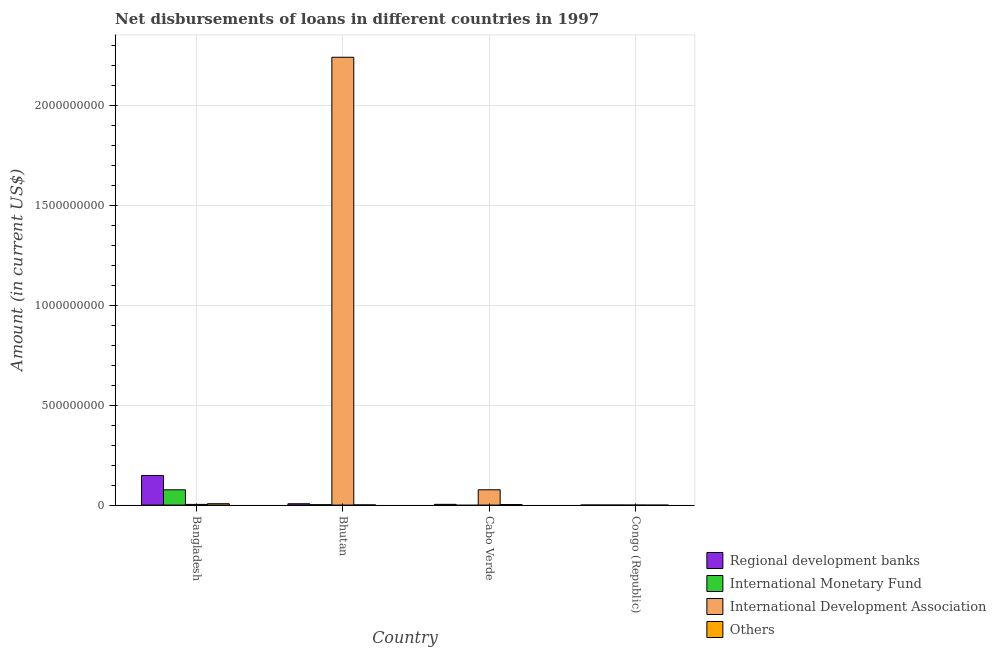How many different coloured bars are there?
Keep it short and to the point. 4. Are the number of bars per tick equal to the number of legend labels?
Keep it short and to the point. No. How many bars are there on the 3rd tick from the right?
Offer a very short reply. 4. What is the label of the 2nd group of bars from the left?
Keep it short and to the point. Bhutan. What is the amount of loan disimbursed by international monetary fund in Bangladesh?
Provide a short and direct response. 7.65e+07. Across all countries, what is the maximum amount of loan disimbursed by international monetary fund?
Your answer should be compact. 7.65e+07. Across all countries, what is the minimum amount of loan disimbursed by international development association?
Make the answer very short. 0. What is the total amount of loan disimbursed by other organisations in the graph?
Your response must be concise. 1.01e+07. What is the difference between the amount of loan disimbursed by international development association in Bhutan and that in Cabo Verde?
Ensure brevity in your answer.  2.17e+09. What is the difference between the amount of loan disimbursed by regional development banks in Congo (Republic) and the amount of loan disimbursed by international monetary fund in Bangladesh?
Make the answer very short. -7.65e+07. What is the average amount of loan disimbursed by other organisations per country?
Provide a short and direct response. 2.52e+06. What is the difference between the amount of loan disimbursed by regional development banks and amount of loan disimbursed by international development association in Bhutan?
Keep it short and to the point. -2.24e+09. In how many countries, is the amount of loan disimbursed by international monetary fund greater than 400000000 US$?
Keep it short and to the point. 0. What is the ratio of the amount of loan disimbursed by international development association in Bangladesh to that in Cabo Verde?
Offer a terse response. 0.04. Is the amount of loan disimbursed by other organisations in Bangladesh less than that in Bhutan?
Provide a succinct answer. No. Is the difference between the amount of loan disimbursed by international monetary fund in Bangladesh and Bhutan greater than the difference between the amount of loan disimbursed by other organisations in Bangladesh and Bhutan?
Offer a terse response. Yes. What is the difference between the highest and the second highest amount of loan disimbursed by other organisations?
Your answer should be very brief. 4.25e+06. What is the difference between the highest and the lowest amount of loan disimbursed by international monetary fund?
Keep it short and to the point. 7.65e+07. How many bars are there?
Make the answer very short. 11. Are all the bars in the graph horizontal?
Offer a very short reply. No. How many countries are there in the graph?
Your response must be concise. 4. What is the difference between two consecutive major ticks on the Y-axis?
Ensure brevity in your answer.  5.00e+08. Are the values on the major ticks of Y-axis written in scientific E-notation?
Make the answer very short. No. Does the graph contain any zero values?
Your response must be concise. Yes. Does the graph contain grids?
Make the answer very short. Yes. How many legend labels are there?
Your response must be concise. 4. How are the legend labels stacked?
Your answer should be very brief. Vertical. What is the title of the graph?
Provide a short and direct response. Net disbursements of loans in different countries in 1997. What is the label or title of the Y-axis?
Your response must be concise. Amount (in current US$). What is the Amount (in current US$) in Regional development banks in Bangladesh?
Provide a succinct answer. 1.48e+08. What is the Amount (in current US$) of International Monetary Fund in Bangladesh?
Ensure brevity in your answer.  7.65e+07. What is the Amount (in current US$) in International Development Association in Bangladesh?
Give a very brief answer. 3.41e+06. What is the Amount (in current US$) in Others in Bangladesh?
Offer a terse response. 6.79e+06. What is the Amount (in current US$) of Regional development banks in Bhutan?
Your response must be concise. 6.68e+06. What is the Amount (in current US$) in International Monetary Fund in Bhutan?
Your answer should be very brief. 1.93e+06. What is the Amount (in current US$) in International Development Association in Bhutan?
Make the answer very short. 2.24e+09. What is the Amount (in current US$) of Others in Bhutan?
Keep it short and to the point. 7.48e+05. What is the Amount (in current US$) of Regional development banks in Cabo Verde?
Give a very brief answer. 3.63e+06. What is the Amount (in current US$) of International Monetary Fund in Cabo Verde?
Your response must be concise. 0. What is the Amount (in current US$) of International Development Association in Cabo Verde?
Provide a short and direct response. 7.65e+07. What is the Amount (in current US$) in Others in Cabo Verde?
Offer a terse response. 2.54e+06. What is the Amount (in current US$) in International Monetary Fund in Congo (Republic)?
Offer a very short reply. 0. What is the Amount (in current US$) of International Development Association in Congo (Republic)?
Offer a terse response. 0. What is the Amount (in current US$) in Others in Congo (Republic)?
Keep it short and to the point. 0. Across all countries, what is the maximum Amount (in current US$) in Regional development banks?
Give a very brief answer. 1.48e+08. Across all countries, what is the maximum Amount (in current US$) of International Monetary Fund?
Offer a terse response. 7.65e+07. Across all countries, what is the maximum Amount (in current US$) of International Development Association?
Provide a succinct answer. 2.24e+09. Across all countries, what is the maximum Amount (in current US$) of Others?
Make the answer very short. 6.79e+06. Across all countries, what is the minimum Amount (in current US$) of International Monetary Fund?
Your response must be concise. 0. Across all countries, what is the minimum Amount (in current US$) in International Development Association?
Provide a short and direct response. 0. Across all countries, what is the minimum Amount (in current US$) of Others?
Your answer should be very brief. 0. What is the total Amount (in current US$) in Regional development banks in the graph?
Your response must be concise. 1.59e+08. What is the total Amount (in current US$) of International Monetary Fund in the graph?
Offer a very short reply. 7.84e+07. What is the total Amount (in current US$) of International Development Association in the graph?
Ensure brevity in your answer.  2.32e+09. What is the total Amount (in current US$) of Others in the graph?
Your response must be concise. 1.01e+07. What is the difference between the Amount (in current US$) of Regional development banks in Bangladesh and that in Bhutan?
Your response must be concise. 1.42e+08. What is the difference between the Amount (in current US$) in International Monetary Fund in Bangladesh and that in Bhutan?
Your answer should be very brief. 7.46e+07. What is the difference between the Amount (in current US$) of International Development Association in Bangladesh and that in Bhutan?
Your response must be concise. -2.24e+09. What is the difference between the Amount (in current US$) of Others in Bangladesh and that in Bhutan?
Your answer should be compact. 6.04e+06. What is the difference between the Amount (in current US$) in Regional development banks in Bangladesh and that in Cabo Verde?
Provide a succinct answer. 1.45e+08. What is the difference between the Amount (in current US$) of International Development Association in Bangladesh and that in Cabo Verde?
Offer a very short reply. -7.31e+07. What is the difference between the Amount (in current US$) in Others in Bangladesh and that in Cabo Verde?
Your answer should be compact. 4.25e+06. What is the difference between the Amount (in current US$) in Regional development banks in Bhutan and that in Cabo Verde?
Provide a short and direct response. 3.05e+06. What is the difference between the Amount (in current US$) in International Development Association in Bhutan and that in Cabo Verde?
Ensure brevity in your answer.  2.17e+09. What is the difference between the Amount (in current US$) in Others in Bhutan and that in Cabo Verde?
Offer a terse response. -1.79e+06. What is the difference between the Amount (in current US$) in Regional development banks in Bangladesh and the Amount (in current US$) in International Monetary Fund in Bhutan?
Your answer should be very brief. 1.46e+08. What is the difference between the Amount (in current US$) in Regional development banks in Bangladesh and the Amount (in current US$) in International Development Association in Bhutan?
Give a very brief answer. -2.09e+09. What is the difference between the Amount (in current US$) in Regional development banks in Bangladesh and the Amount (in current US$) in Others in Bhutan?
Offer a very short reply. 1.48e+08. What is the difference between the Amount (in current US$) of International Monetary Fund in Bangladesh and the Amount (in current US$) of International Development Association in Bhutan?
Provide a short and direct response. -2.17e+09. What is the difference between the Amount (in current US$) of International Monetary Fund in Bangladesh and the Amount (in current US$) of Others in Bhutan?
Offer a terse response. 7.57e+07. What is the difference between the Amount (in current US$) of International Development Association in Bangladesh and the Amount (in current US$) of Others in Bhutan?
Your answer should be compact. 2.66e+06. What is the difference between the Amount (in current US$) in Regional development banks in Bangladesh and the Amount (in current US$) in International Development Association in Cabo Verde?
Your answer should be compact. 7.18e+07. What is the difference between the Amount (in current US$) in Regional development banks in Bangladesh and the Amount (in current US$) in Others in Cabo Verde?
Offer a very short reply. 1.46e+08. What is the difference between the Amount (in current US$) of International Monetary Fund in Bangladesh and the Amount (in current US$) of International Development Association in Cabo Verde?
Offer a terse response. -7000. What is the difference between the Amount (in current US$) of International Monetary Fund in Bangladesh and the Amount (in current US$) of Others in Cabo Verde?
Ensure brevity in your answer.  7.39e+07. What is the difference between the Amount (in current US$) of International Development Association in Bangladesh and the Amount (in current US$) of Others in Cabo Verde?
Provide a succinct answer. 8.71e+05. What is the difference between the Amount (in current US$) in Regional development banks in Bhutan and the Amount (in current US$) in International Development Association in Cabo Verde?
Your answer should be compact. -6.98e+07. What is the difference between the Amount (in current US$) in Regional development banks in Bhutan and the Amount (in current US$) in Others in Cabo Verde?
Your answer should be very brief. 4.14e+06. What is the difference between the Amount (in current US$) in International Monetary Fund in Bhutan and the Amount (in current US$) in International Development Association in Cabo Verde?
Keep it short and to the point. -7.46e+07. What is the difference between the Amount (in current US$) of International Monetary Fund in Bhutan and the Amount (in current US$) of Others in Cabo Verde?
Offer a very short reply. -6.13e+05. What is the difference between the Amount (in current US$) of International Development Association in Bhutan and the Amount (in current US$) of Others in Cabo Verde?
Offer a terse response. 2.24e+09. What is the average Amount (in current US$) of Regional development banks per country?
Make the answer very short. 3.96e+07. What is the average Amount (in current US$) of International Monetary Fund per country?
Your answer should be very brief. 1.96e+07. What is the average Amount (in current US$) in International Development Association per country?
Offer a terse response. 5.81e+08. What is the average Amount (in current US$) in Others per country?
Ensure brevity in your answer.  2.52e+06. What is the difference between the Amount (in current US$) in Regional development banks and Amount (in current US$) in International Monetary Fund in Bangladesh?
Your answer should be very brief. 7.18e+07. What is the difference between the Amount (in current US$) in Regional development banks and Amount (in current US$) in International Development Association in Bangladesh?
Provide a short and direct response. 1.45e+08. What is the difference between the Amount (in current US$) in Regional development banks and Amount (in current US$) in Others in Bangladesh?
Provide a short and direct response. 1.41e+08. What is the difference between the Amount (in current US$) of International Monetary Fund and Amount (in current US$) of International Development Association in Bangladesh?
Provide a succinct answer. 7.31e+07. What is the difference between the Amount (in current US$) in International Monetary Fund and Amount (in current US$) in Others in Bangladesh?
Ensure brevity in your answer.  6.97e+07. What is the difference between the Amount (in current US$) of International Development Association and Amount (in current US$) of Others in Bangladesh?
Keep it short and to the point. -3.38e+06. What is the difference between the Amount (in current US$) in Regional development banks and Amount (in current US$) in International Monetary Fund in Bhutan?
Your answer should be very brief. 4.76e+06. What is the difference between the Amount (in current US$) in Regional development banks and Amount (in current US$) in International Development Association in Bhutan?
Offer a terse response. -2.24e+09. What is the difference between the Amount (in current US$) in Regional development banks and Amount (in current US$) in Others in Bhutan?
Provide a succinct answer. 5.94e+06. What is the difference between the Amount (in current US$) of International Monetary Fund and Amount (in current US$) of International Development Association in Bhutan?
Provide a short and direct response. -2.24e+09. What is the difference between the Amount (in current US$) of International Monetary Fund and Amount (in current US$) of Others in Bhutan?
Give a very brief answer. 1.18e+06. What is the difference between the Amount (in current US$) of International Development Association and Amount (in current US$) of Others in Bhutan?
Offer a terse response. 2.24e+09. What is the difference between the Amount (in current US$) in Regional development banks and Amount (in current US$) in International Development Association in Cabo Verde?
Offer a terse response. -7.29e+07. What is the difference between the Amount (in current US$) in Regional development banks and Amount (in current US$) in Others in Cabo Verde?
Keep it short and to the point. 1.09e+06. What is the difference between the Amount (in current US$) in International Development Association and Amount (in current US$) in Others in Cabo Verde?
Ensure brevity in your answer.  7.40e+07. What is the ratio of the Amount (in current US$) of Regional development banks in Bangladesh to that in Bhutan?
Your answer should be very brief. 22.19. What is the ratio of the Amount (in current US$) in International Monetary Fund in Bangladesh to that in Bhutan?
Your answer should be compact. 39.69. What is the ratio of the Amount (in current US$) of International Development Association in Bangladesh to that in Bhutan?
Your answer should be compact. 0. What is the ratio of the Amount (in current US$) in Others in Bangladesh to that in Bhutan?
Your answer should be very brief. 9.08. What is the ratio of the Amount (in current US$) of Regional development banks in Bangladesh to that in Cabo Verde?
Make the answer very short. 40.8. What is the ratio of the Amount (in current US$) of International Development Association in Bangladesh to that in Cabo Verde?
Provide a succinct answer. 0.04. What is the ratio of the Amount (in current US$) of Others in Bangladesh to that in Cabo Verde?
Ensure brevity in your answer.  2.67. What is the ratio of the Amount (in current US$) of Regional development banks in Bhutan to that in Cabo Verde?
Make the answer very short. 1.84. What is the ratio of the Amount (in current US$) of International Development Association in Bhutan to that in Cabo Verde?
Provide a succinct answer. 29.31. What is the ratio of the Amount (in current US$) in Others in Bhutan to that in Cabo Verde?
Your answer should be very brief. 0.29. What is the difference between the highest and the second highest Amount (in current US$) of Regional development banks?
Offer a very short reply. 1.42e+08. What is the difference between the highest and the second highest Amount (in current US$) in International Development Association?
Give a very brief answer. 2.17e+09. What is the difference between the highest and the second highest Amount (in current US$) of Others?
Your answer should be compact. 4.25e+06. What is the difference between the highest and the lowest Amount (in current US$) in Regional development banks?
Your response must be concise. 1.48e+08. What is the difference between the highest and the lowest Amount (in current US$) in International Monetary Fund?
Keep it short and to the point. 7.65e+07. What is the difference between the highest and the lowest Amount (in current US$) of International Development Association?
Your answer should be compact. 2.24e+09. What is the difference between the highest and the lowest Amount (in current US$) in Others?
Make the answer very short. 6.79e+06. 